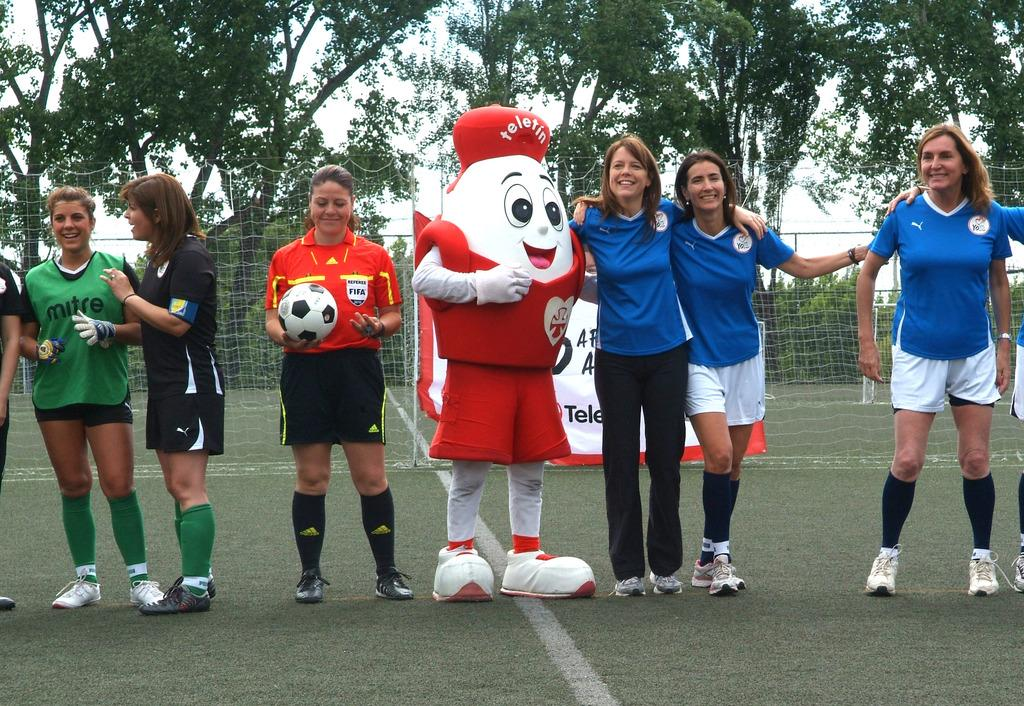What type of vegetation can be seen in the image? There are trees in the image. What structure is present in the image? There is a fence in the image. Who or what is visible in the image? There are people standing in the image. What type of eggs can be seen in the image? There are no eggs present in the image. What is the consistency of the jelly in the image? There is no jelly present in the image. 